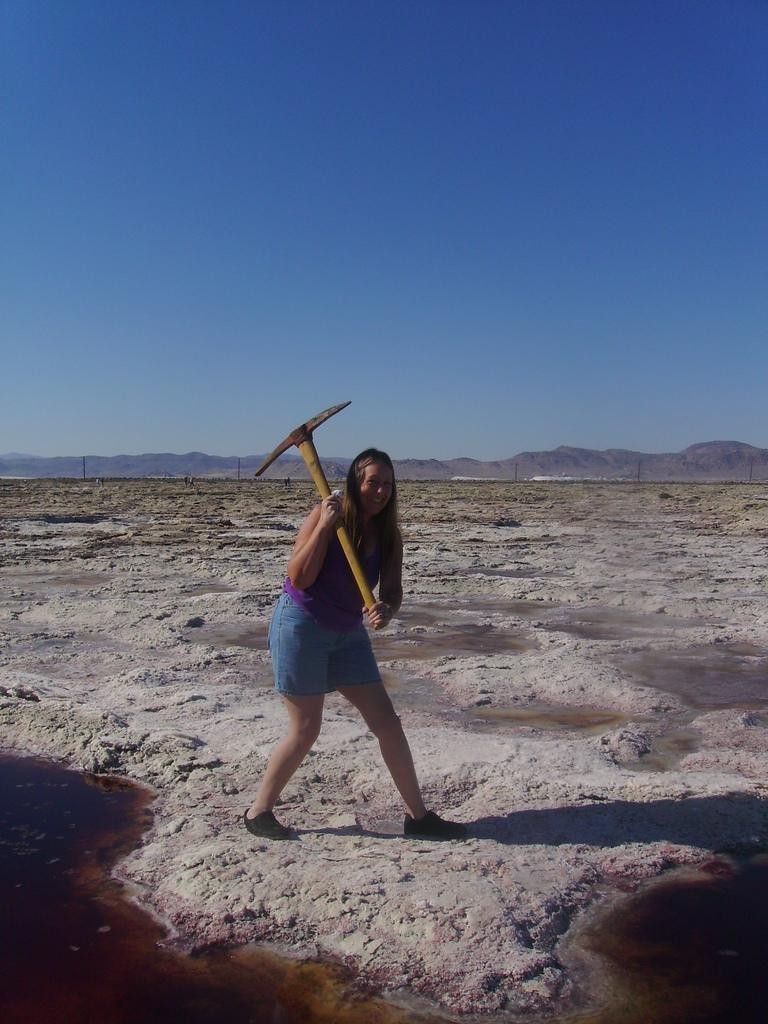Who is present in the image? There is a woman in the image. What is the woman holding in the image? The woman is holding a digging instrument. What can be seen in the background of the image? There is water and a hill visible in the image. What is the color of the sky in the image? The sky is blue in the image. What type of picture is the woman holding in her memory? There is no indication in the image that the woman is holding a picture in her memory, as the image only shows her holding a digging instrument. 